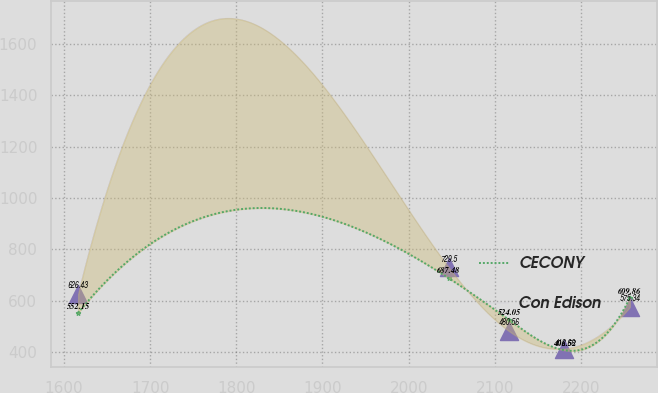Convert chart to OTSL. <chart><loc_0><loc_0><loc_500><loc_500><line_chart><ecel><fcel>CECONY<fcel>Con Edison<nl><fcel>1616.33<fcel>552.15<fcel>626.43<nl><fcel>2046.56<fcel>687.48<fcel>729.5<nl><fcel>2116.84<fcel>524.05<fcel>480.56<nl><fcel>2180.88<fcel>406.52<fcel>412.66<nl><fcel>2256.76<fcel>609.86<fcel>575.34<nl></chart> 